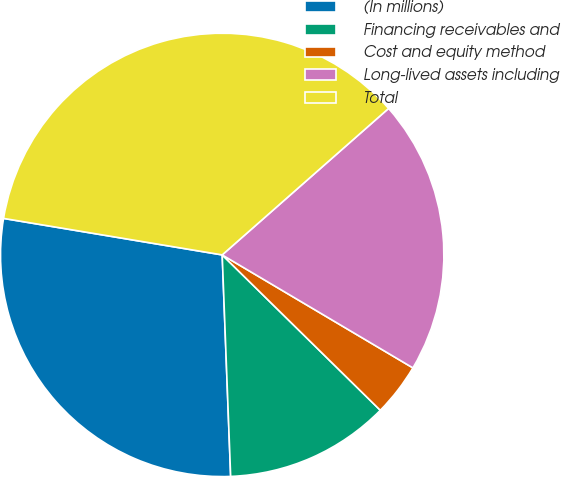Convert chart. <chart><loc_0><loc_0><loc_500><loc_500><pie_chart><fcel>(In millions)<fcel>Financing receivables and<fcel>Cost and equity method<fcel>Long-lived assets including<fcel>Total<nl><fcel>28.24%<fcel>12.03%<fcel>3.85%<fcel>20.0%<fcel>35.88%<nl></chart> 